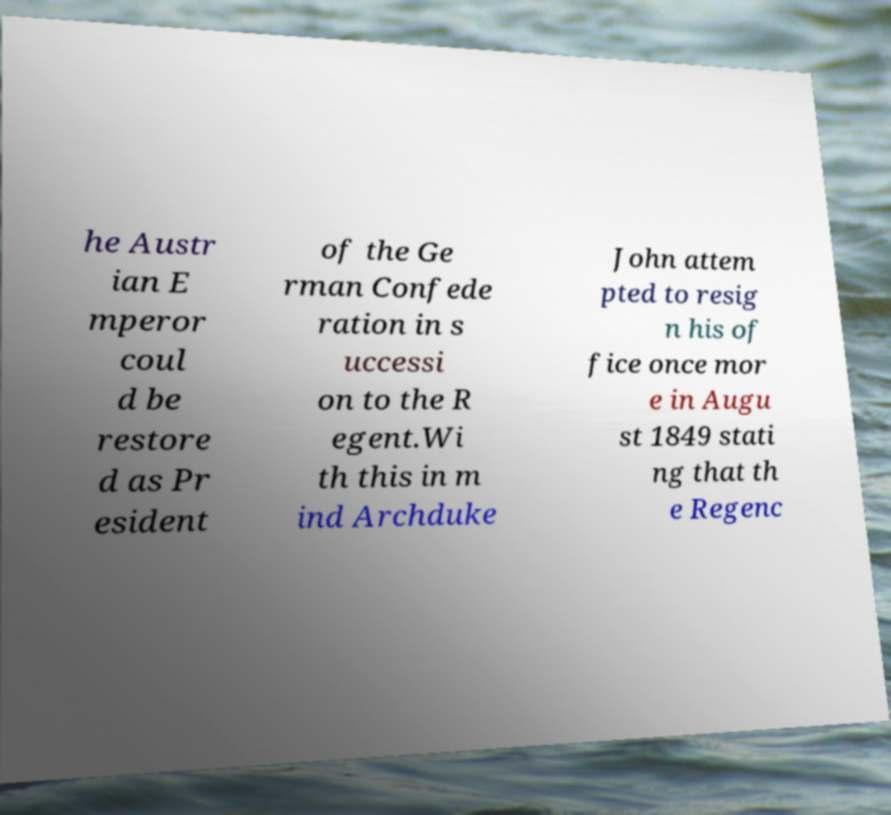Please read and relay the text visible in this image. What does it say? he Austr ian E mperor coul d be restore d as Pr esident of the Ge rman Confede ration in s uccessi on to the R egent.Wi th this in m ind Archduke John attem pted to resig n his of fice once mor e in Augu st 1849 stati ng that th e Regenc 